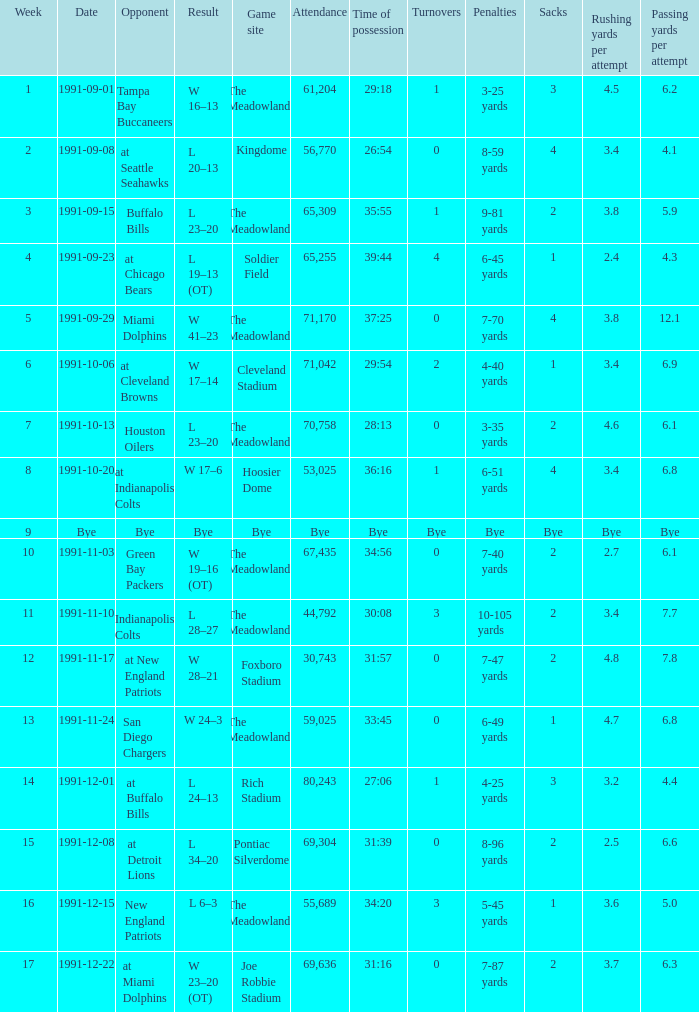What was the Attendance of the Game at Hoosier Dome? 53025.0. Could you help me parse every detail presented in this table? {'header': ['Week', 'Date', 'Opponent', 'Result', 'Game site', 'Attendance', 'Time of possession', 'Turnovers', 'Penalties', 'Sacks', 'Rushing yards per attempt', 'Passing yards per attempt'], 'rows': [['1', '1991-09-01', 'Tampa Bay Buccaneers', 'W 16–13', 'The Meadowlands', '61,204', '29:18', '1', '3-25 yards', '3', '4.5', '6.2'], ['2', '1991-09-08', 'at Seattle Seahawks', 'L 20–13', 'Kingdome', '56,770', '26:54', '0', '8-59 yards', '4', '3.4', '4.1'], ['3', '1991-09-15', 'Buffalo Bills', 'L 23–20', 'The Meadowlands', '65,309', '35:55', '1', '9-81 yards', '2', '3.8', '5.9'], ['4', '1991-09-23', 'at Chicago Bears', 'L 19–13 (OT)', 'Soldier Field', '65,255', '39:44', '4', '6-45 yards', '1', '2.4', '4.3'], ['5', '1991-09-29', 'Miami Dolphins', 'W 41–23', 'The Meadowlands', '71,170', '37:25', '0', '7-70 yards', '4', '3.8', '12.1'], ['6', '1991-10-06', 'at Cleveland Browns', 'W 17–14', 'Cleveland Stadium', '71,042', '29:54', '2', '4-40 yards', '1', '3.4', '6.9'], ['7', '1991-10-13', 'Houston Oilers', 'L 23–20', 'The Meadowlands', '70,758', '28:13', '0', '3-35 yards', '2', '4.6', '6.1'], ['8', '1991-10-20', 'at Indianapolis Colts', 'W 17–6', 'Hoosier Dome', '53,025', '36:16', '1', '6-51 yards', '4', '3.4', '6.8'], ['9', 'Bye', 'Bye', 'Bye', 'Bye', 'Bye', 'Bye', 'Bye', 'Bye', 'Bye', 'Bye', 'Bye'], ['10', '1991-11-03', 'Green Bay Packers', 'W 19–16 (OT)', 'The Meadowlands', '67,435', '34:56', '0', '7-40 yards', '2', '2.7', '6.1'], ['11', '1991-11-10', 'Indianapolis Colts', 'L 28–27', 'The Meadowlands', '44,792', '30:08', '3', '10-105 yards', '2', '3.4', '7.7'], ['12', '1991-11-17', 'at New England Patriots', 'W 28–21', 'Foxboro Stadium', '30,743', '31:57', '0', '7-47 yards', '2', '4.8', '7.8'], ['13', '1991-11-24', 'San Diego Chargers', 'W 24–3', 'The Meadowlands', '59,025', '33:45', '0', '6-49 yards', '1', '4.7', '6.8'], ['14', '1991-12-01', 'at Buffalo Bills', 'L 24–13', 'Rich Stadium', '80,243', '27:06', '1', '4-25 yards', '3', '3.2', '4.4'], ['15', '1991-12-08', 'at Detroit Lions', 'L 34–20', 'Pontiac Silverdome', '69,304', '31:39', '0', '8-96 yards', '2', '2.5', '6.6'], ['16', '1991-12-15', 'New England Patriots', 'L 6–3', 'The Meadowlands', '55,689', '34:20', '3', '5-45 yards', '1', '3.6', '5.0'], ['17', '1991-12-22', 'at Miami Dolphins', 'W 23–20 (OT)', 'Joe Robbie Stadium', '69,636', '31:16', '0', '7-87 yards', '2', '3.7', '6.3']]} 